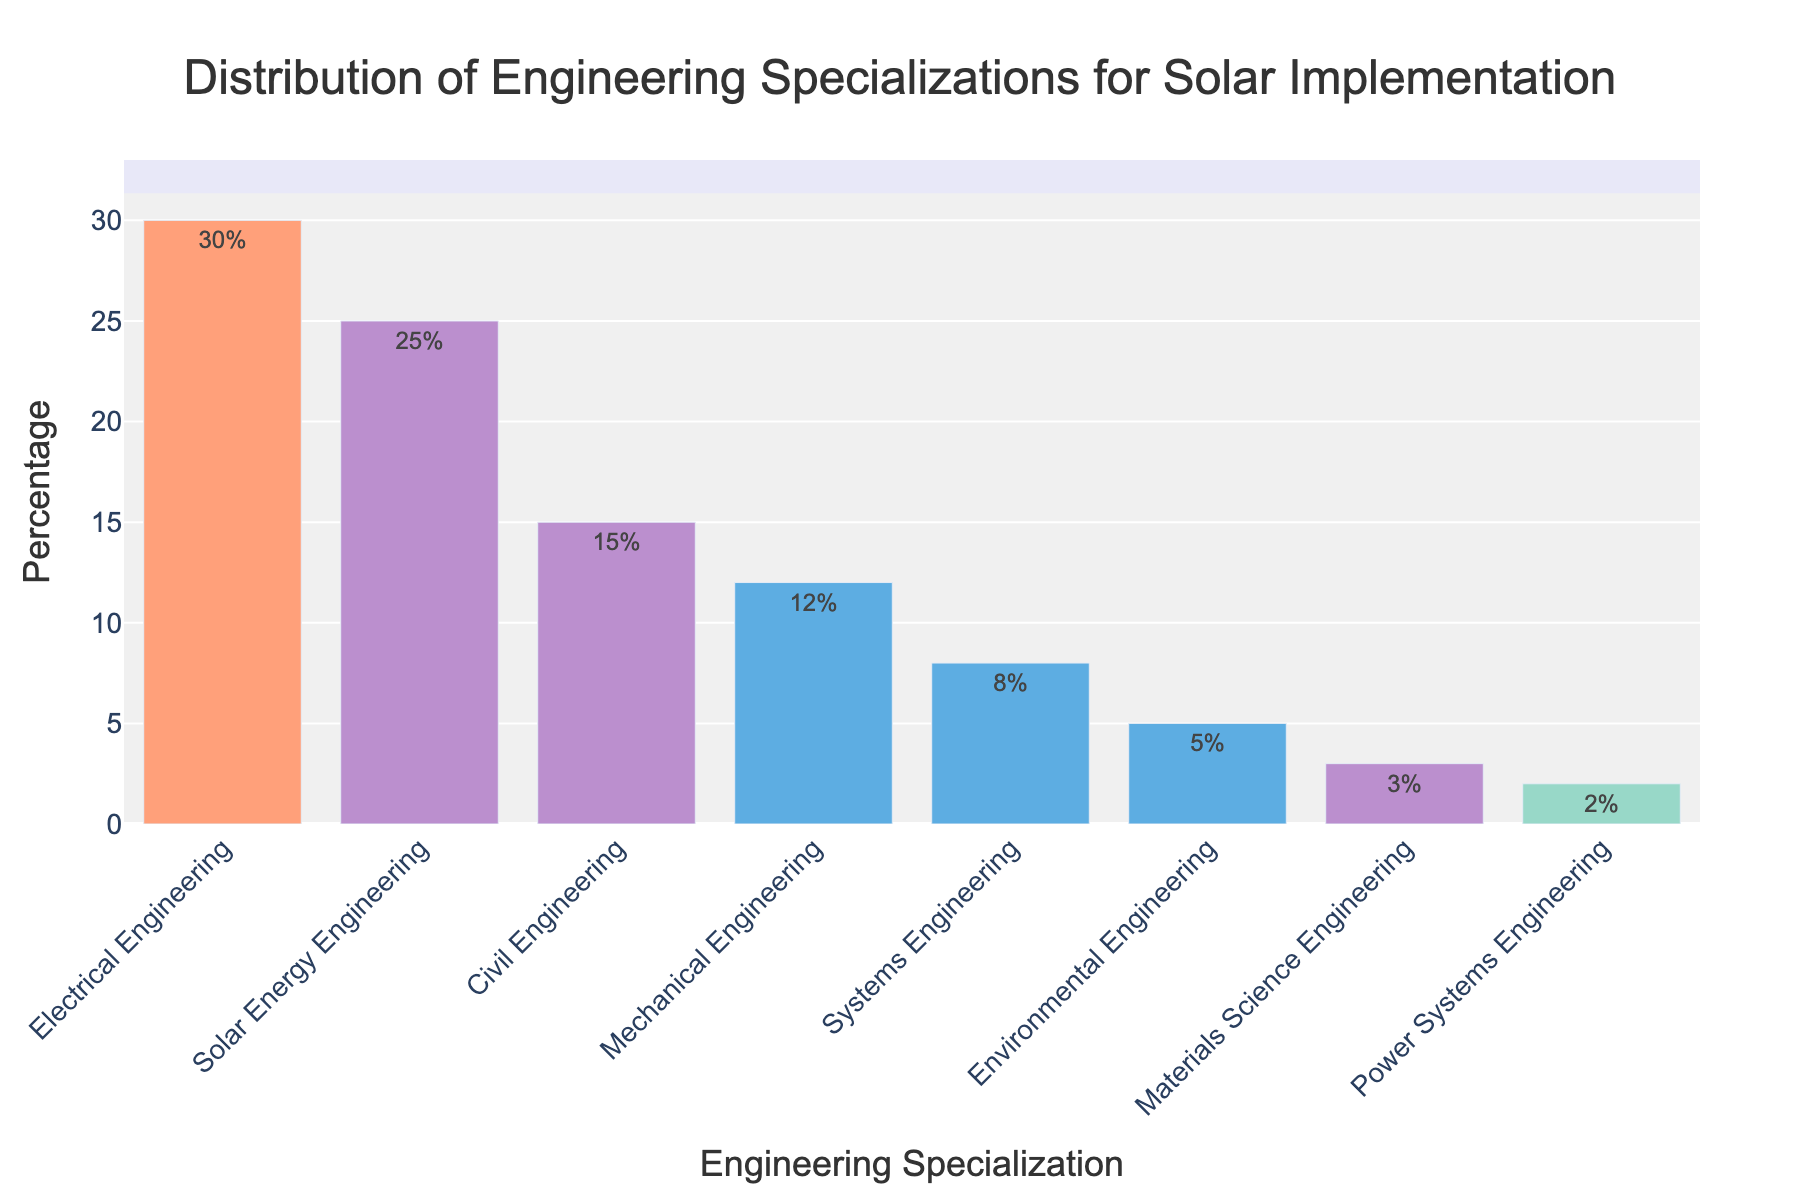Which specialization has the highest percentage? The bar representing Electrical Engineering is the tallest among all, with a label showing 30%.
Answer: Electrical Engineering Which specialization has the lowest percentage? The bar representing Power Systems Engineering is the shortest among all, with a label showing 2%.
Answer: Power Systems Engineering Which two specializations together make up over 50% of the required engineers? Electrical Engineering at 30% and Solar Energy Engineering at 25% together make 55%, which is over 50%.
Answer: Electrical Engineering and Solar Energy Engineering How much higher is the percentage of Mechanical Engineering compared to Systems Engineering? Mechanical Engineering is at 12%, while Systems Engineering is at 8%. The difference is 12% - 8% = 4%.
Answer: 4% What is the combined percentage for Civil Engineering, Systems Engineering, and Environmental Engineering? Civil Engineering is 15%, Systems Engineering is 8%, and Environmental Engineering is 5%. Their combined percentage is 15% + 8% + 5% = 28%.
Answer: 28% How does the percentage of Solar Energy Engineering compare to Mechanical Engineering? Solar Energy Engineering is at 25% and Mechanical Engineering is at 12%. Solar Energy Engineering is more by 25% - 12% = 13%.
Answer: 13% What’s the percentage difference between the highest and the lowest specialization? The highest percentage is for Electrical Engineering at 30%, and the lowest is for Power Systems Engineering at 2%. The difference is 30% - 2% = 28%.
Answer: 28% Is the percentage for Environmental Engineering higher or lower than Materials Science Engineering? The bar for Environmental Engineering shows 5% which is higher than Materials Science Engineering's 3%.
Answer: Higher Which specialization categories together comprise exactly 18% of the total requirement? Systems Engineering is 8% and Environmental Engineering is 5%, and Materials Science Engineering is 3%. Adding these, 8% + 5% + 3% = 16%. We need to adjust the choice such that Civil Engineering added with Power Systems Engineering equals exactly 18%. Civil Engineering is 15% and Power Systems Engineering is 2%, making 15% + 2% = 17%. Upon reviewing, Environmental 5% + Materials Science 3% + Power Systems 2% sums to 10%. When added with Systems Engineer 8%, total is 18%.
Answer: Systems Engineering, Environmental Engineering, and Power Systems Engineering 